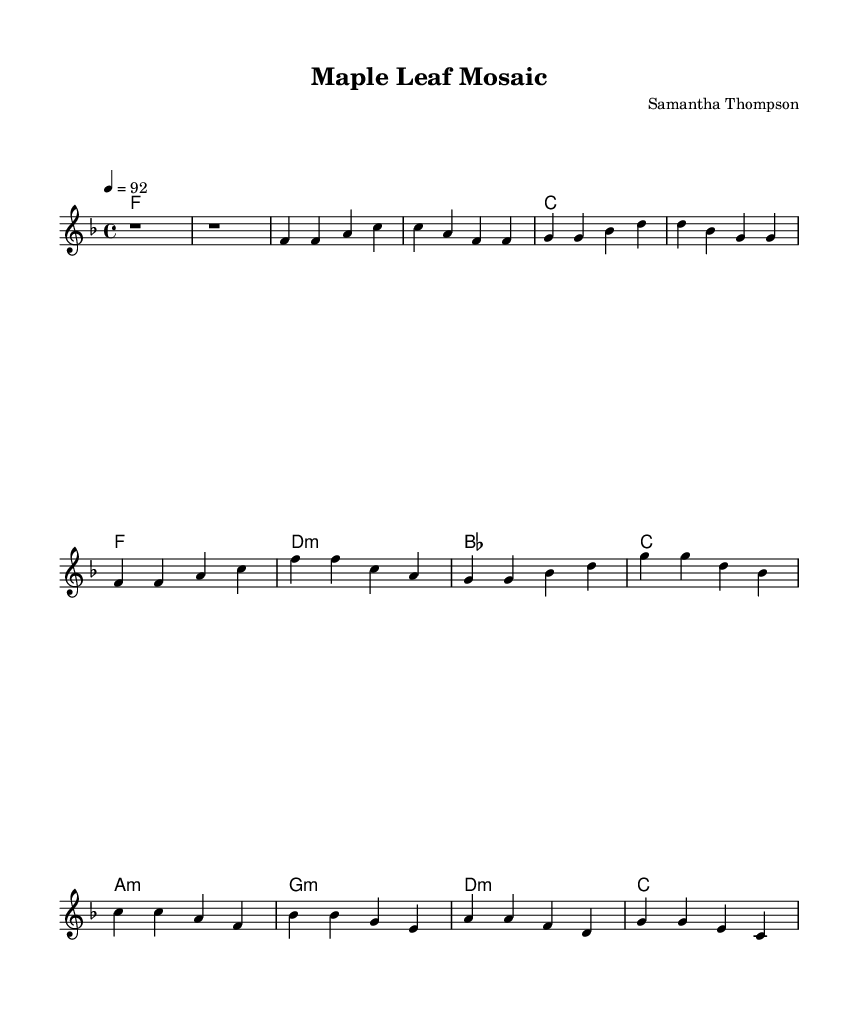What is the key signature of this music? The key signature is F major, which has one flat (B flat). It can be identified at the beginning of the sheet music right after the time signature.
Answer: F major What is the time signature of this music? The time signature is 4/4, as indicated by the number at the beginning of the score next to the key signature. This means there are four beats in each measure.
Answer: 4/4 What is the tempo marking of the piece? The tempo marking indicates a speed of 92 beats per minute, located at the tempo indication in the score. This tells the performer how fast to play the piece.
Answer: 92 How many measures are there in the chorus? The chorus consists of four measures, which can be counted by looking at the section labeled as the Chorus in the sheet music. Each measure is separated by vertical lines.
Answer: 4 What is the chord progression in the first verse? The chord progression in the first verse includes F, C, G, and D. This can be determined by analyzing the chord symbols written above the melody notes in the verse.
Answer: F, C, G, D What type of musical form is represented in this piece? The musical form consists of verses, a chorus, and a bridge, which is typical of many soul songs to provide a mix of lyrical ideas and emotional expression. Analyzing the structure of the music shows this arrangement.
Answer: Verse-Chorus-Bridge 